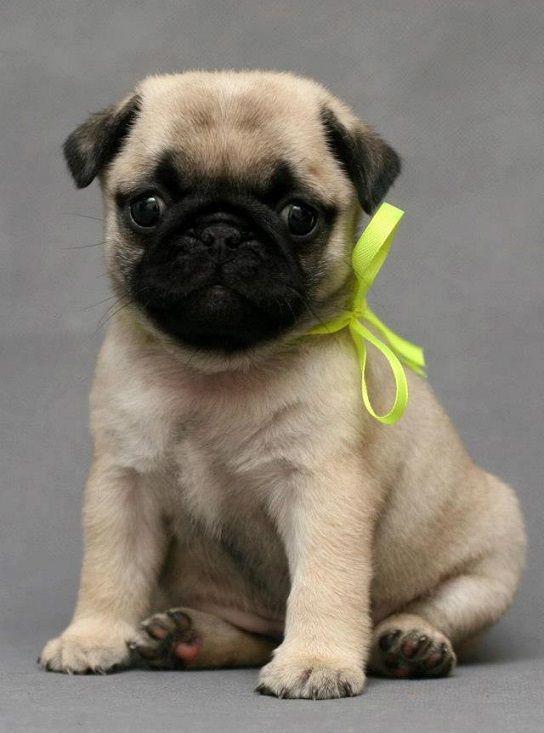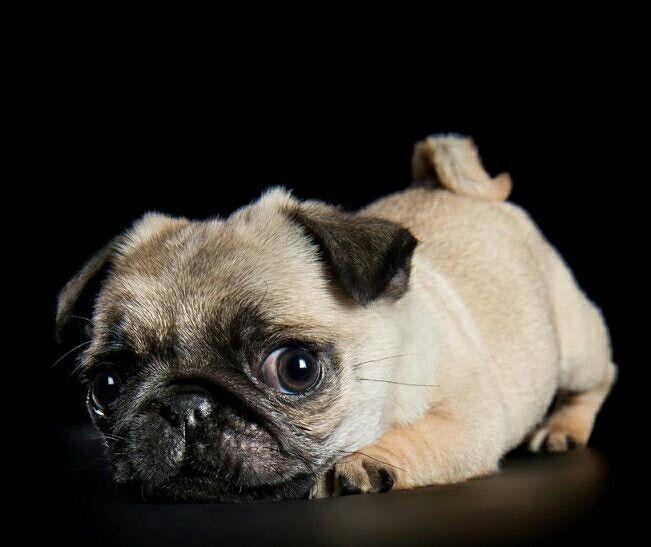The first image is the image on the left, the second image is the image on the right. Considering the images on both sides, is "The right image contains exactly three pug dogs." valid? Answer yes or no. No. The first image is the image on the left, the second image is the image on the right. Evaluate the accuracy of this statement regarding the images: "There are at most two dogs.". Is it true? Answer yes or no. Yes. 